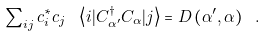<formula> <loc_0><loc_0><loc_500><loc_500>\sum \nolimits _ { i j } c ^ { * } _ { i } c _ { j } \ \left \langle i | C ^ { \dagger } _ { \alpha ^ { \prime } } C _ { \alpha } | j \right \rangle = D \left ( \alpha ^ { \prime } , \alpha \right ) \ .</formula> 